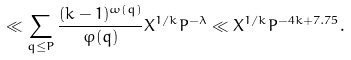<formula> <loc_0><loc_0><loc_500><loc_500>\ll \sum _ { q \leq P } \frac { ( k - 1 ) ^ { \omega ( q ) } } { \varphi ( q ) } X ^ { 1 / k } P ^ { - \lambda } \ll X ^ { 1 / k } P ^ { - 4 k + 7 . 7 5 } .</formula> 